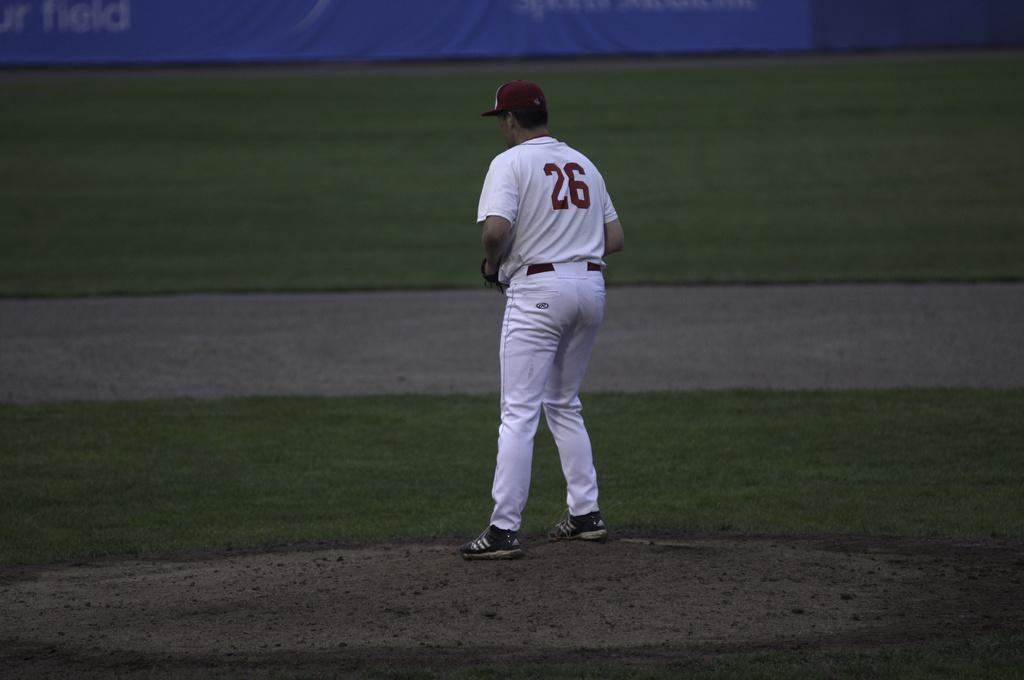<image>
Create a compact narrative representing the image presented. A baseball player in white with number 26 on his shirt is on the field of play. 